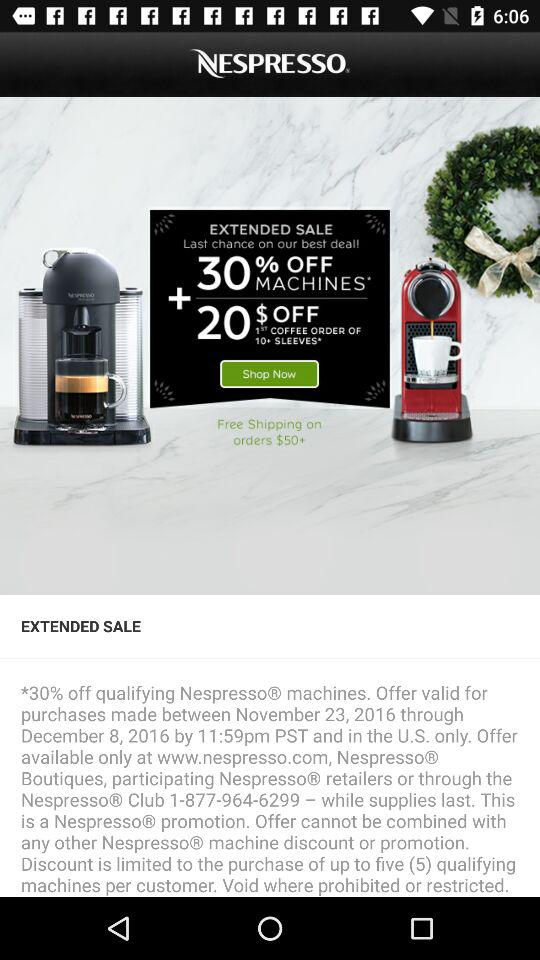What percentage is off on the machines? There is 30% off on the machines. 